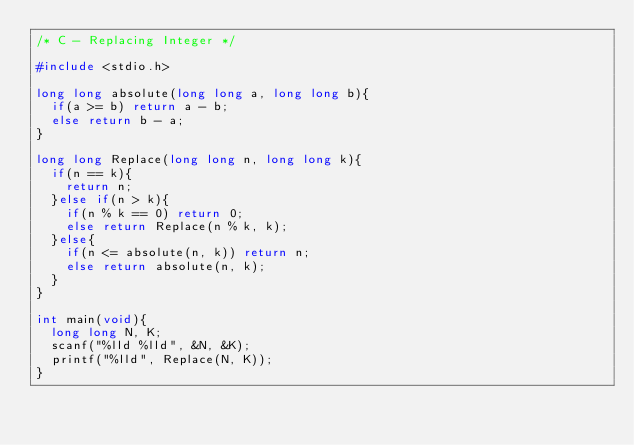<code> <loc_0><loc_0><loc_500><loc_500><_C_>/* C - Replacing Integer */

#include <stdio.h>

long long absolute(long long a, long long b){
  if(a >= b) return a - b;
  else return b - a;
}

long long Replace(long long n, long long k){
  if(n == k){
    return n;
  }else if(n > k){
    if(n % k == 0) return 0;
    else return Replace(n % k, k);
  }else{
    if(n <= absolute(n, k)) return n;
    else return absolute(n, k);
  }
}

int main(void){
  long long N, K;
  scanf("%lld %lld", &N, &K);
  printf("%lld", Replace(N, K));
}
</code> 